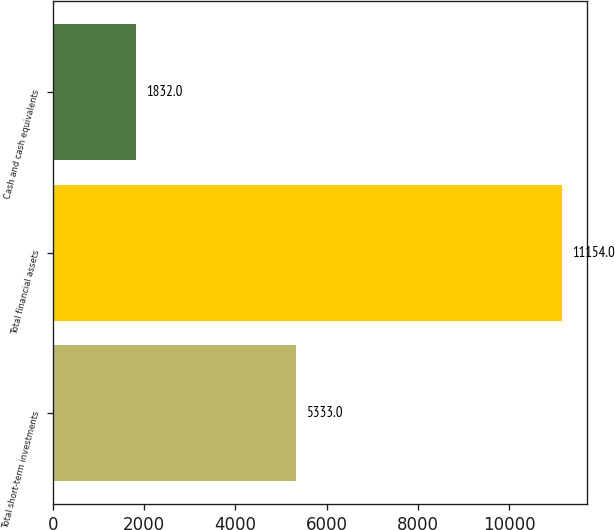Convert chart. <chart><loc_0><loc_0><loc_500><loc_500><bar_chart><fcel>Total short-term investments<fcel>Total financial assets<fcel>Cash and cash equivalents<nl><fcel>5333<fcel>11154<fcel>1832<nl></chart> 